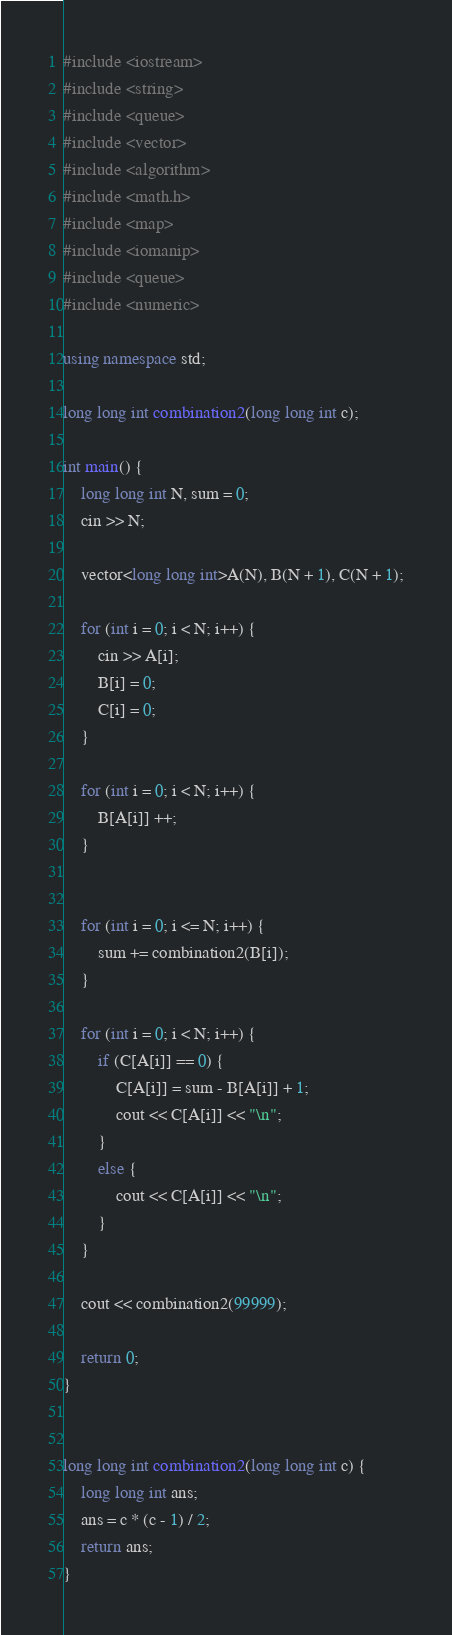Convert code to text. <code><loc_0><loc_0><loc_500><loc_500><_C++_>#include <iostream>
#include <string>
#include <queue>
#include <vector>
#include <algorithm>
#include <math.h>
#include <map>
#include <iomanip>
#include <queue>
#include <numeric>

using namespace std;

long long int combination2(long long int c);

int main() {
    long long int N, sum = 0;
    cin >> N;

    vector<long long int>A(N), B(N + 1), C(N + 1);

    for (int i = 0; i < N; i++) {
        cin >> A[i];
        B[i] = 0;
        C[i] = 0;
    }

    for (int i = 0; i < N; i++) {
        B[A[i]] ++;
    }


    for (int i = 0; i <= N; i++) {
        sum += combination2(B[i]);
    }

    for (int i = 0; i < N; i++) {
        if (C[A[i]] == 0) {
            C[A[i]] = sum - B[A[i]] + 1;
            cout << C[A[i]] << "\n";
        }
        else {
            cout << C[A[i]] << "\n";
        }
    }

    cout << combination2(99999);

    return 0;
}


long long int combination2(long long int c) {
    long long int ans;
    ans = c * (c - 1) / 2;
    return ans;
}

</code> 